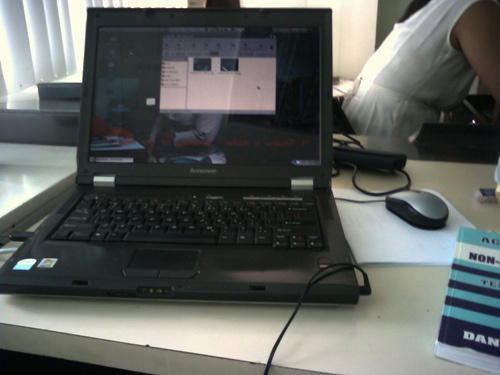Describe the objects in this image and their specific colors. I can see laptop in lightgray, black, gray, and darkgray tones, people in lightgray, black, gray, darkgray, and ivory tones, book in lightgray, teal, black, and darkgray tones, chair in lightgray, black, and gray tones, and mouse in lightgray, black, gray, and darkgray tones in this image. 